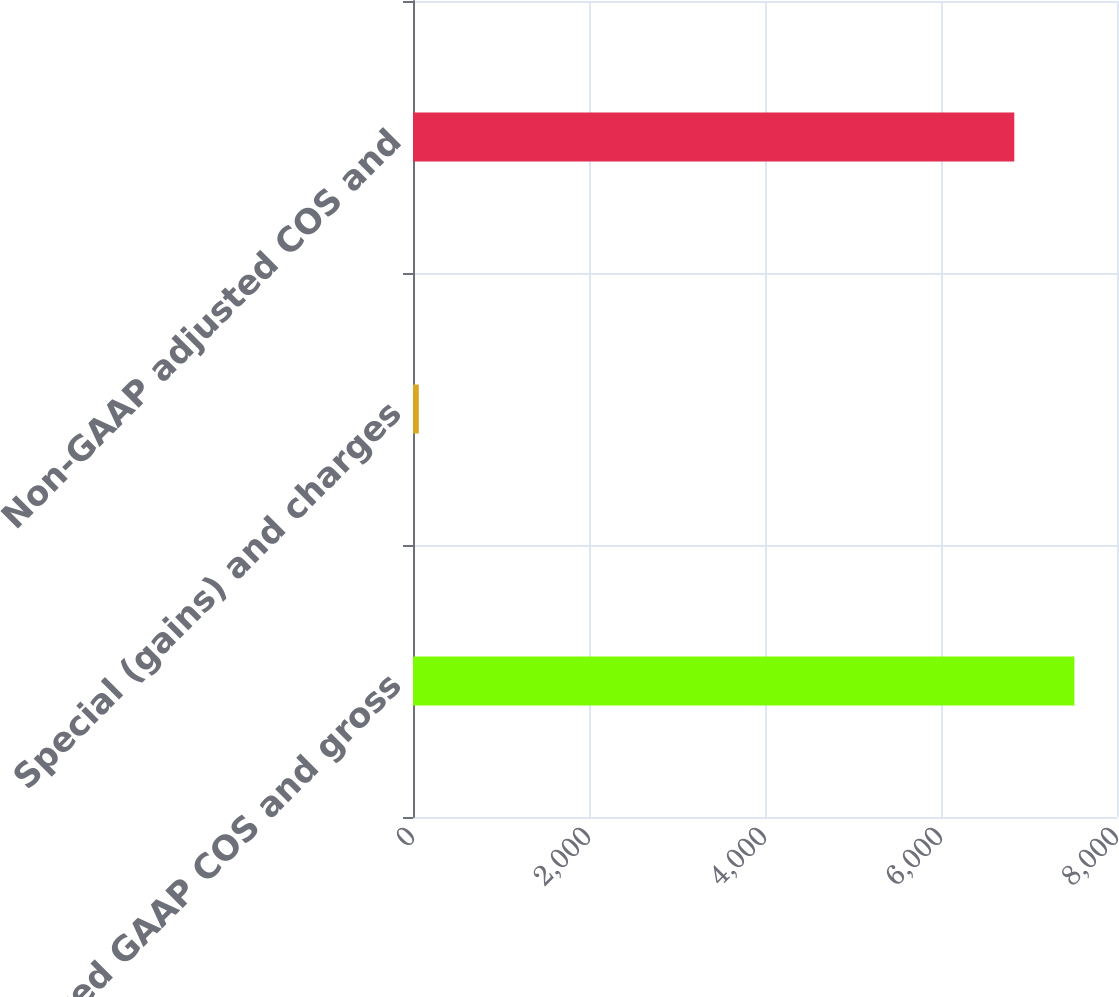Convert chart. <chart><loc_0><loc_0><loc_500><loc_500><bar_chart><fcel>Reported GAAP COS and gross<fcel>Special (gains) and charges<fcel>Non-GAAP adjusted COS and<nl><fcel>7516.19<fcel>66<fcel>6832.9<nl></chart> 